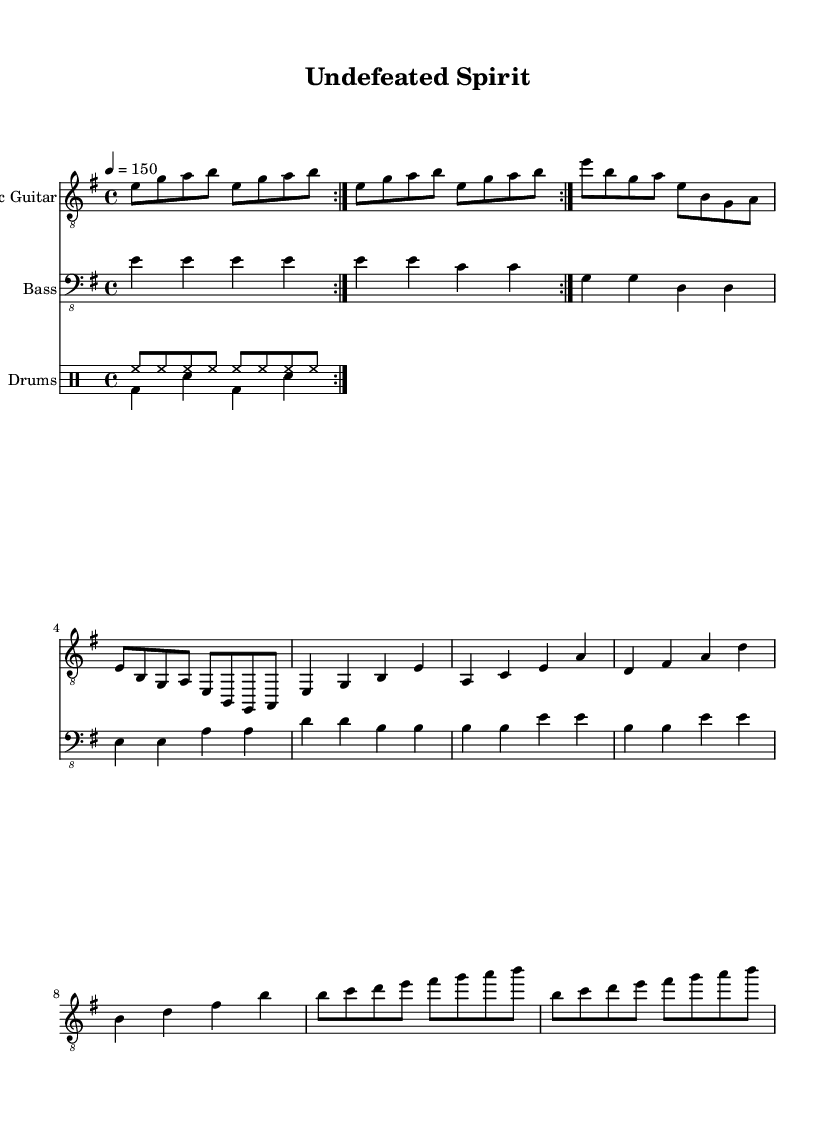What is the key signature of this music? The key signature is E minor, which contains one sharp (F#). This is determined by looking at the key signature indicated at the beginning of the staff.
Answer: E minor What is the time signature of this music? The time signature is 4/4, denoting that there are four beats in each measure and a quarter note receives one beat. This is indicated at the start of the composition.
Answer: 4/4 What is the tempo marking for this music? The tempo marking is quarter note equals 150, which means the piece should be played at a pace of 150 beats per minute. This is stated at the beginning of the score.
Answer: 150 How many measures are there in the chorus section? The chorus section contains four measures, as indicated by the grouping of notes in the corresponding section of the score layout.
Answer: 4 What is the main rhythmic pattern used in the drums? The main rhythmic pattern used in the drums is a basic rock beat, which typically consists of a combination of bass drum, snare drum, and hi-hat. This can be observed in the drum notation sections.
Answer: Basic rock beat Which instrument has a repeated volta at the beginning? The electric guitar has a repeated volta at the beginning, which is notated with the repeat signs indicating that the section should be played twice. This can be seen at the start of the electric guitar part.
Answer: Electric Guitar What type of metal music does this sheet represent? This sheet represents industrial metal with themes of mental toughness and overcoming adversity, evident from the title "Undefeated Spirit" and the aggressive musical elements.
Answer: Industrial metal 